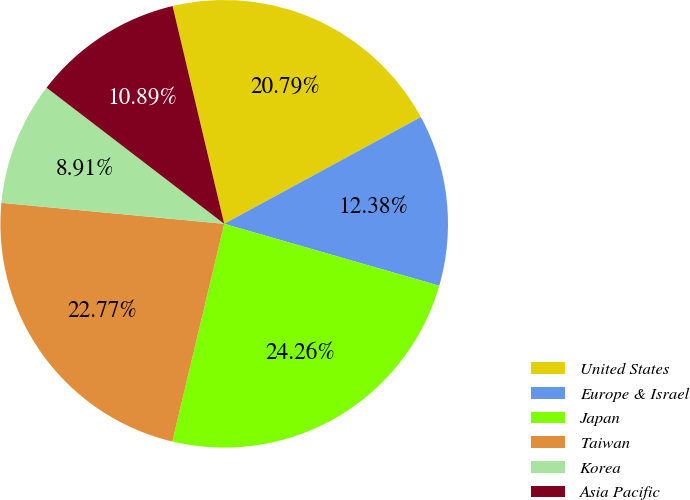<chart> <loc_0><loc_0><loc_500><loc_500><pie_chart><fcel>United States<fcel>Europe & Israel<fcel>Japan<fcel>Taiwan<fcel>Korea<fcel>Asia Pacific<nl><fcel>20.79%<fcel>12.38%<fcel>24.26%<fcel>22.77%<fcel>8.91%<fcel>10.89%<nl></chart> 